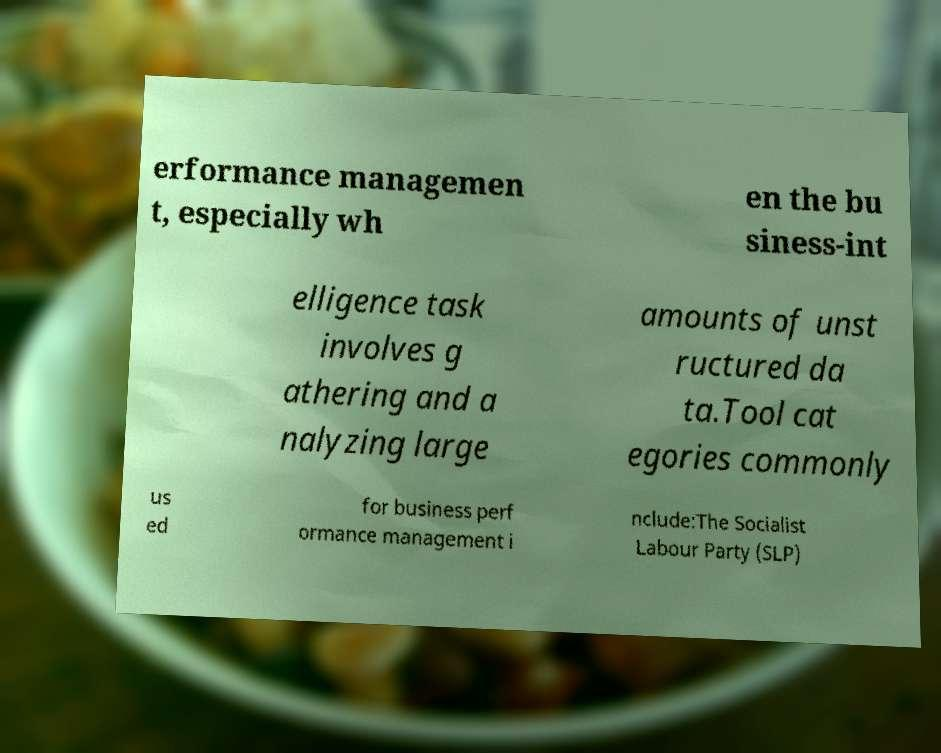There's text embedded in this image that I need extracted. Can you transcribe it verbatim? erformance managemen t, especially wh en the bu siness-int elligence task involves g athering and a nalyzing large amounts of unst ructured da ta.Tool cat egories commonly us ed for business perf ormance management i nclude:The Socialist Labour Party (SLP) 